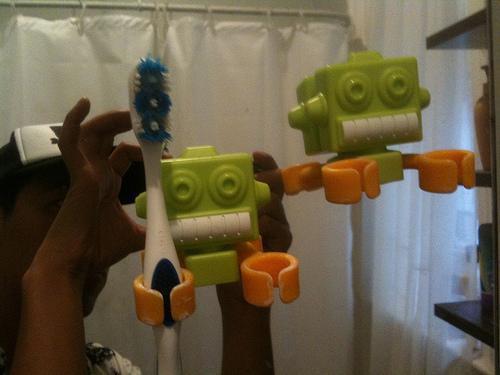How many toothbrushes are there?
Give a very brief answer. 1. 